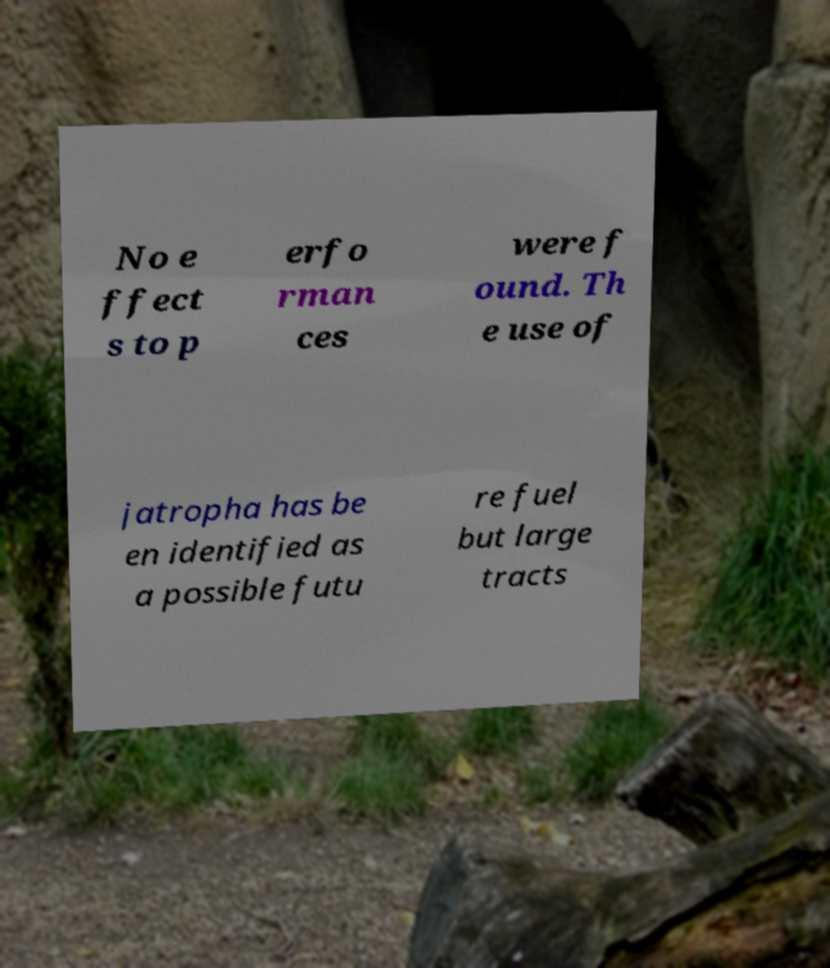I need the written content from this picture converted into text. Can you do that? No e ffect s to p erfo rman ces were f ound. Th e use of jatropha has be en identified as a possible futu re fuel but large tracts 